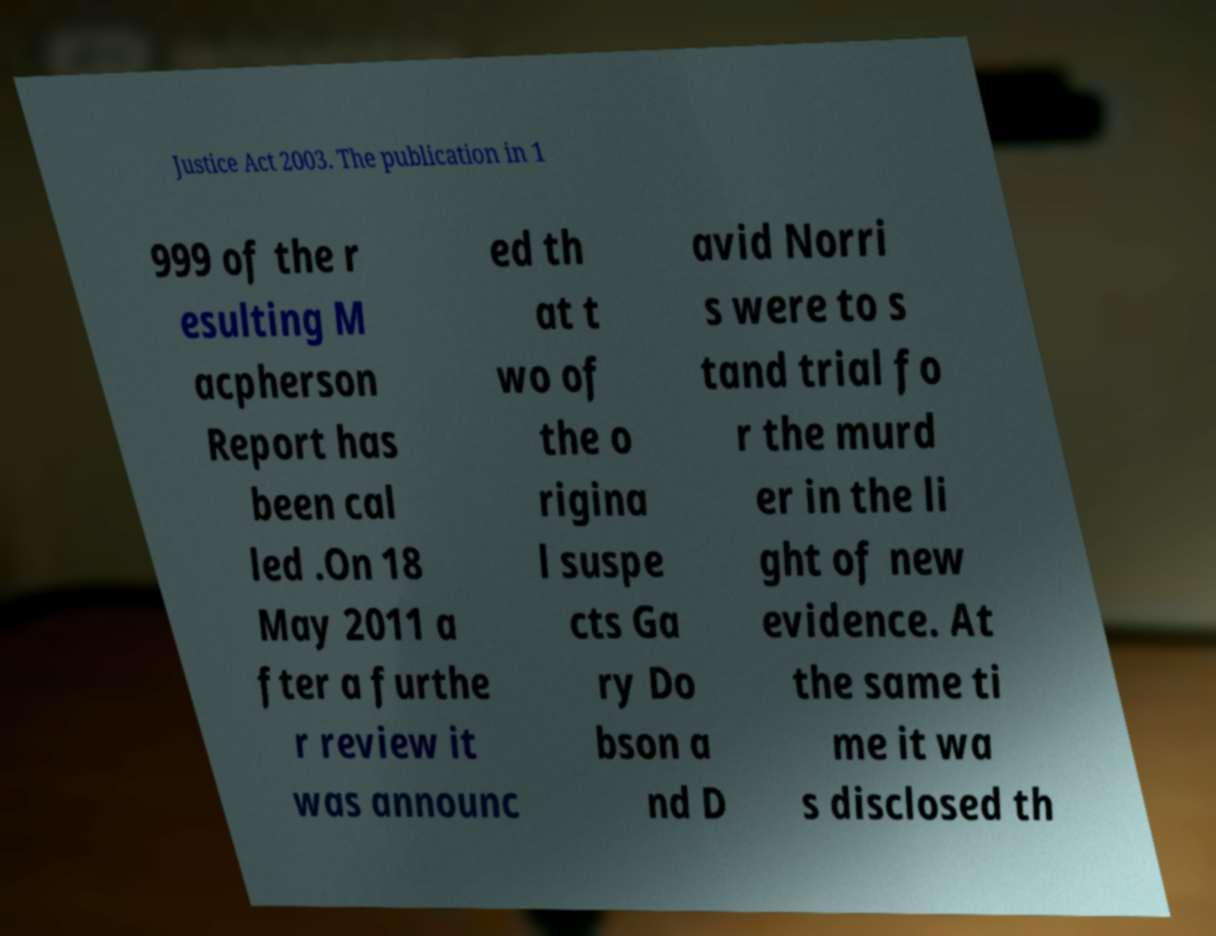Please identify and transcribe the text found in this image. Justice Act 2003. The publication in 1 999 of the r esulting M acpherson Report has been cal led .On 18 May 2011 a fter a furthe r review it was announc ed th at t wo of the o rigina l suspe cts Ga ry Do bson a nd D avid Norri s were to s tand trial fo r the murd er in the li ght of new evidence. At the same ti me it wa s disclosed th 